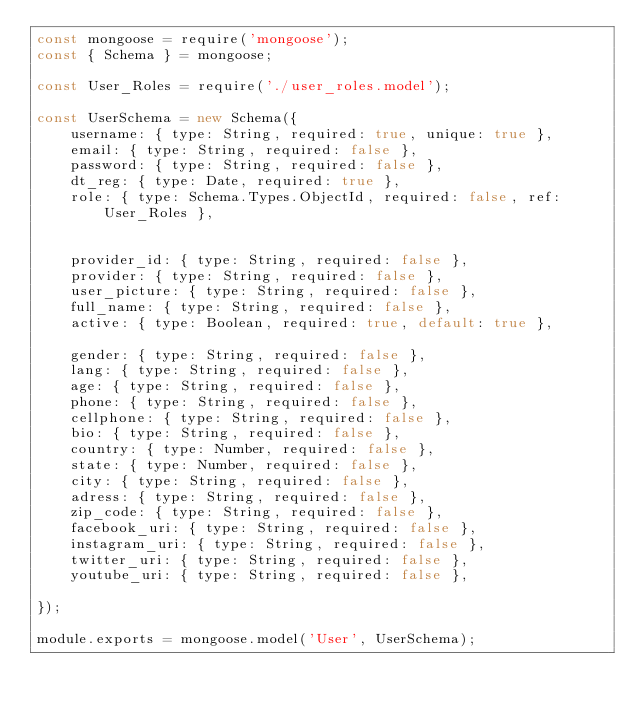<code> <loc_0><loc_0><loc_500><loc_500><_JavaScript_>const mongoose = require('mongoose');
const { Schema } = mongoose;

const User_Roles = require('./user_roles.model');

const UserSchema = new Schema({
    username: { type: String, required: true, unique: true },
    email: { type: String, required: false },
    password: { type: String, required: false },
    dt_reg: { type: Date, required: true },
    role: { type: Schema.Types.ObjectId, required: false, ref: User_Roles },

    
    provider_id: { type: String, required: false },
    provider: { type: String, required: false },
    user_picture: { type: String, required: false },
    full_name: { type: String, required: false },
    active: { type: Boolean, required: true, default: true },
   
    gender: { type: String, required: false },
    lang: { type: String, required: false },
    age: { type: String, required: false },
    phone: { type: String, required: false },
    cellphone: { type: String, required: false },
    bio: { type: String, required: false },
    country: { type: Number, required: false },
    state: { type: Number, required: false },
    city: { type: String, required: false },
    adress: { type: String, required: false },
    zip_code: { type: String, required: false },
    facebook_uri: { type: String, required: false },
    instagram_uri: { type: String, required: false },
    twitter_uri: { type: String, required: false },
    youtube_uri: { type: String, required: false },

});

module.exports = mongoose.model('User', UserSchema);
</code> 